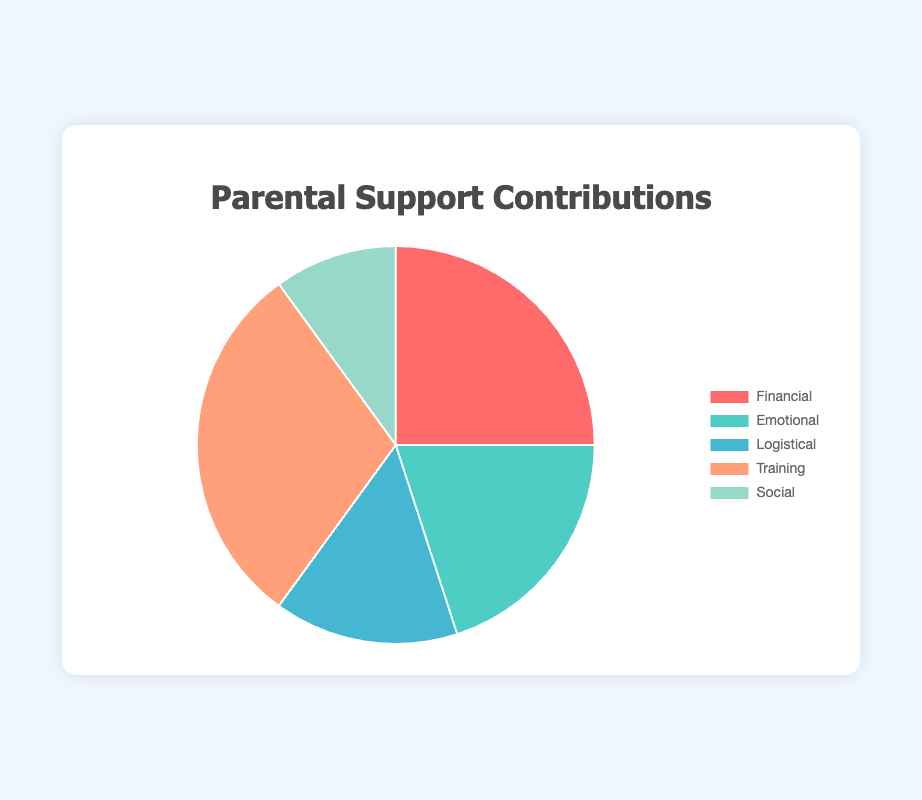What percentage of the contributions is dedicated to emotional support? The pie chart labels show that the emotional support sector represents 20%.
Answer: 20% What is the difference in contribution percentage between training and logistical support? The training contribution is 30%, and the logistical contribution is 15%. The difference is 30% - 15% = 15%.
Answer: 15% Which category has the smallest contribution percentage? By looking at the pie chart, the social support category has the smallest sector, indicating 10%.
Answer: Social support Which category has the highest percentage of contributions? The chart shows that the training category has the largest sector, representing 30%.
Answer: Training What is the combined contribution percentage of financial and logistical support? The financial contribution is 25%, and the logistical contribution is 15%. The combined percentage is 25% + 15% = 40%.
Answer: 40% By how much does financial support exceed emotional support? Financial support is 25%, and emotional support is 20%. The difference is 25% - 20% = 5%.
Answer: 5% What proportion of the total contributions is accounted for by both emotional and social support combined? Emotional support is 20%, and social support is 10%. Combined, they account for 20% + 10% = 30%.
Answer: 30% What is the average contribution percentage across all categories? The sum of all contribution percentages is 25% + 20% + 15% + 30% + 10% = 100%. There are 5 categories, so the average is 100% / 5 = 20%.
Answer: 20% If the percentage contributions of training and social support were swapped, what would be the new percentage for each? Initially, training is 30% and social support is 10%. Swapping them would change training to 10% and social support to 30%.
Answer: Training: 10%, Social support: 30% Compare the combined contribution percentage of logistical and social support to that of financial support. Logistical is 15% and social is 10%, combined they make 25%. Financial support is also 25%. Thus, the combined percentage of logistical and social is equal to financial support.
Answer: Equal 